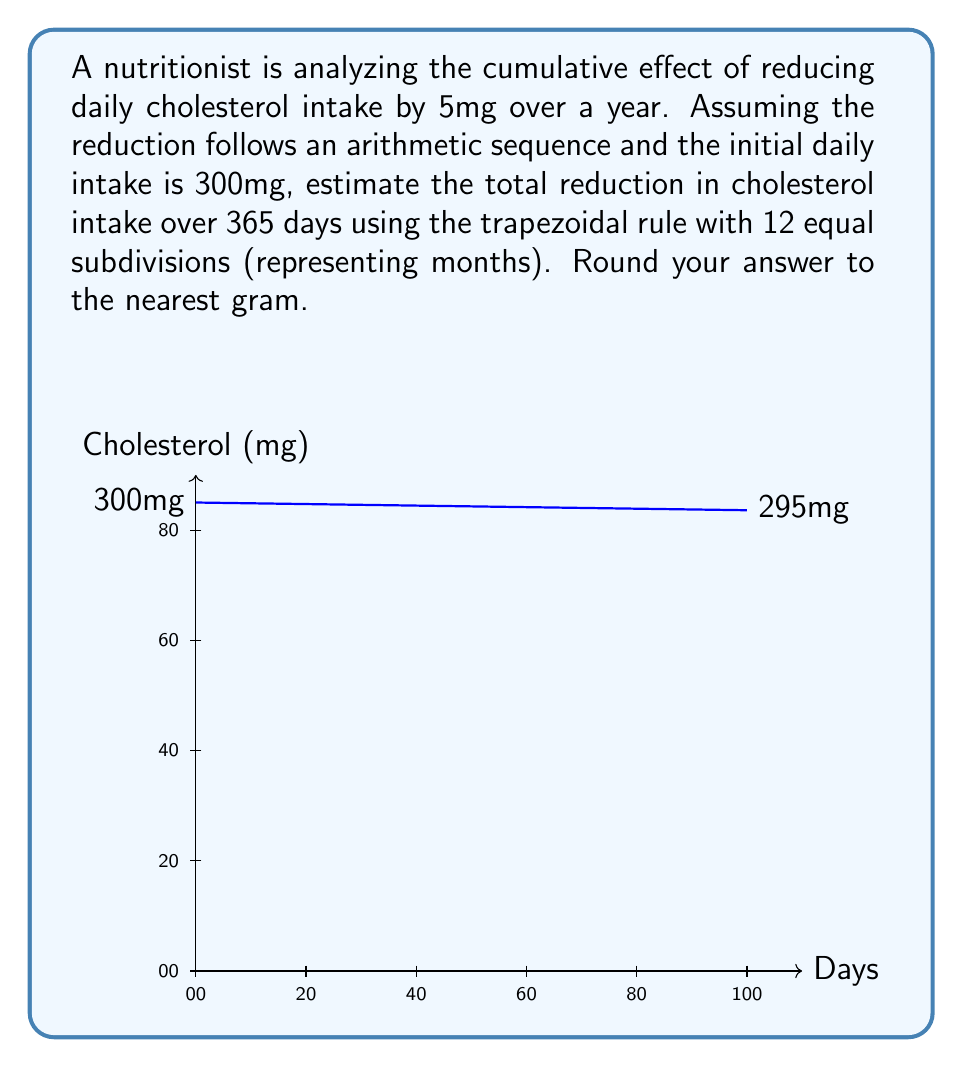Can you solve this math problem? Let's approach this step-by-step:

1) The function representing daily cholesterol intake is:
   $$f(x) = 300 - \frac{5x}{365}$$
   where x is the number of days.

2) We need to calculate the area under this curve from x = 0 to x = 365.

3) The trapezoidal rule with n subdivisions is given by:
   $$\int_a^b f(x)dx \approx \frac{b-a}{2n}\left[f(a) + 2\sum_{k=1}^{n-1}f(x_k) + f(b)\right]$$

4) Here, a = 0, b = 365, and n = 12.

5) We need to calculate f(x_k) for k = 0 to 12:
   $$x_k = k \cdot \frac{365}{12} = 30.4167k$$
   $$f(x_k) = 300 - \frac{5(30.4167k)}{365} = 300 - 0.4167k$$

6) Applying the trapezoidal rule:
   $$\text{Total Reduction} \approx \frac{365}{2(12)}\left[f(0) + 2\sum_{k=1}^{11}f(x_k) + f(365)\right]$$
   $$= 15.2083\left[300 + 2\sum_{k=1}^{11}(300 - 0.4167k) + 295\right]$$

7) Calculating the sum:
   $$\sum_{k=1}^{11}(300 - 0.4167k) = 3300 - 0.4167\sum_{k=1}^{11}k = 3300 - 0.4167(66) = 3272.5$$

8) Substituting back:
   $$\text{Total Reduction} \approx 15.2083[300 + 2(3272.5) + 295]$$
   $$= 15.2083[7140] = 108,587.1mg$$

9) Rounding to the nearest gram:
   $$108,587.1mg \approx 109g$$
Answer: 109g 